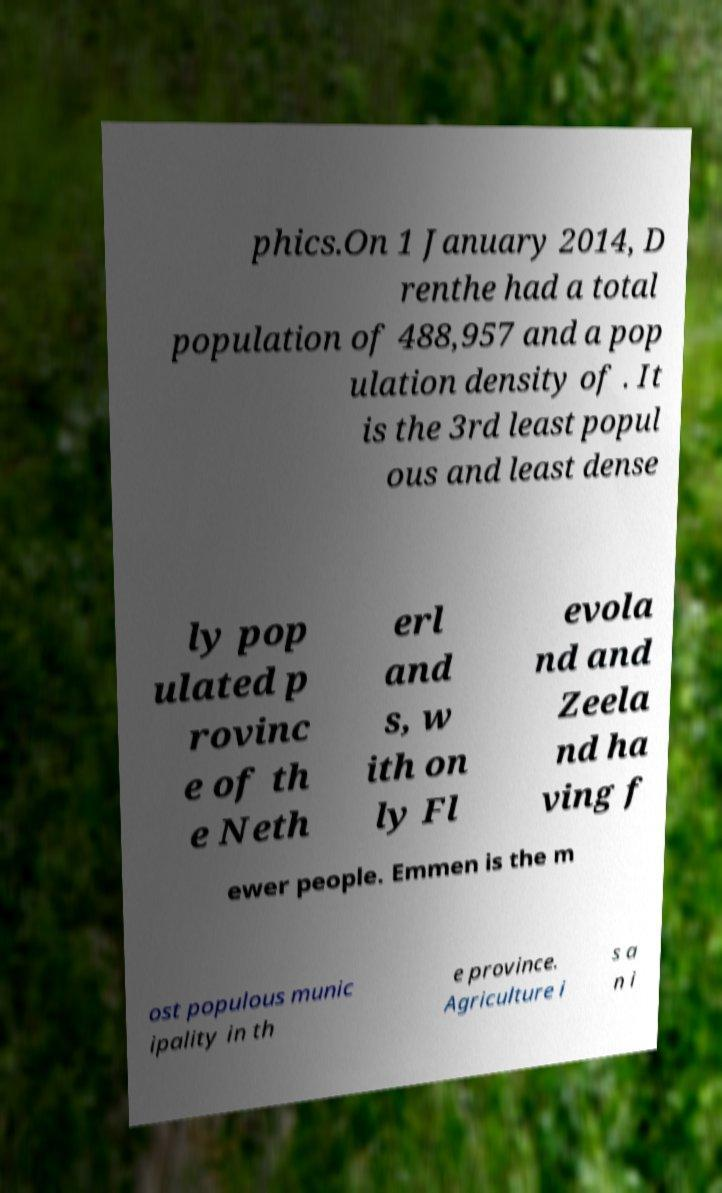Can you accurately transcribe the text from the provided image for me? phics.On 1 January 2014, D renthe had a total population of 488,957 and a pop ulation density of . It is the 3rd least popul ous and least dense ly pop ulated p rovinc e of th e Neth erl and s, w ith on ly Fl evola nd and Zeela nd ha ving f ewer people. Emmen is the m ost populous munic ipality in th e province. Agriculture i s a n i 